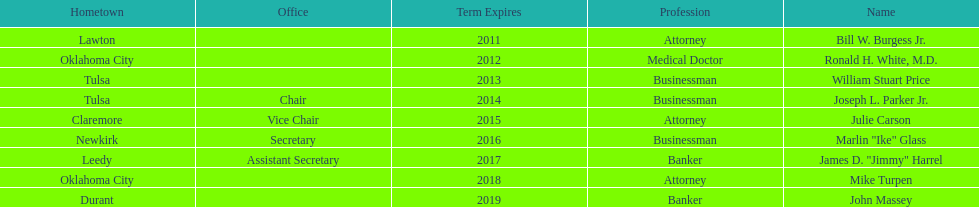Which regents are from tulsa? William Stuart Price, Joseph L. Parker Jr. Which of these is not joseph parker, jr.? William Stuart Price. 